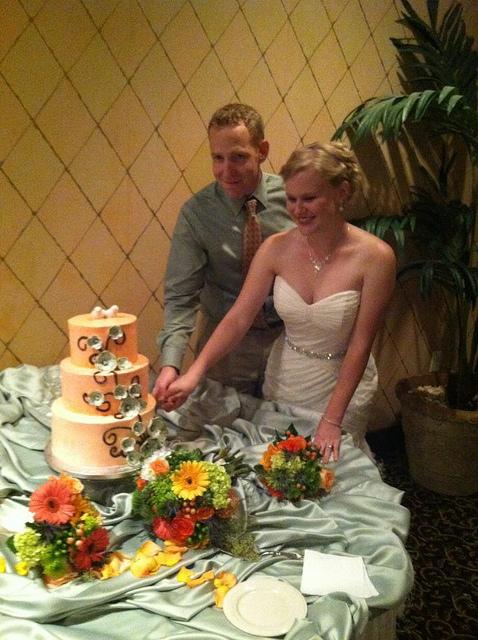What color is the cake?
Quick response, please. Orange. Do the women have dark hair?
Quick response, please. No. What are the expressions of the couple?
Write a very short answer. Happy. What color are the flowers?
Short answer required. Yellow. What style of wedding dress is she wearing?
Short answer required. Strapless. 